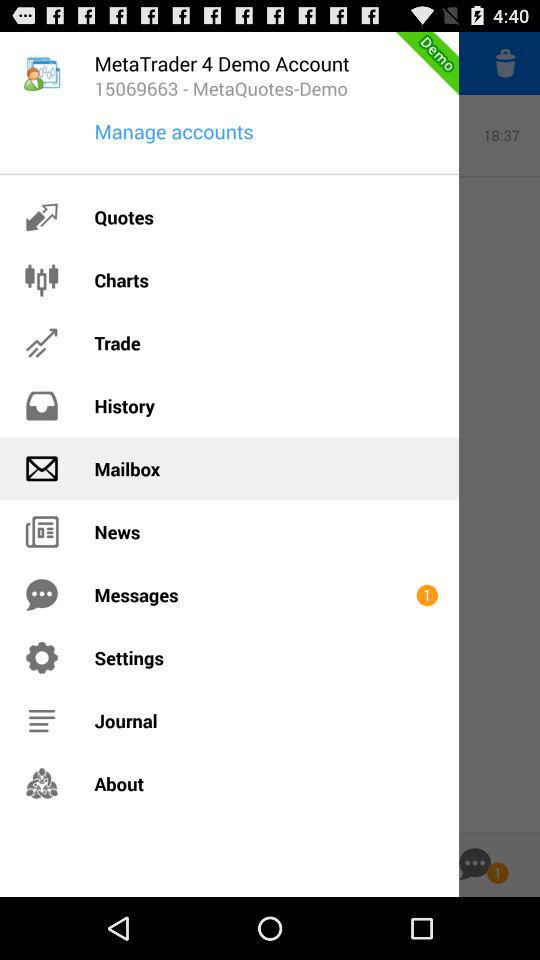How many messages are received? There is 1 received message. 